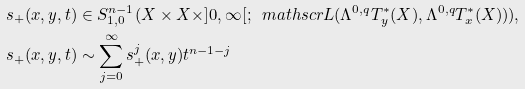<formula> <loc_0><loc_0><loc_500><loc_500>& s _ { + } ( x , y , t ) \in S ^ { n - 1 } _ { 1 , 0 } ( X \times X \times ] 0 , \infty [ ; \, \ m a t h s c r L ( \Lambda ^ { 0 , q } T ^ { * } _ { y } ( X ) , \Lambda ^ { 0 , q } T ^ { * } _ { x } ( X ) ) ) , \\ & s _ { + } ( x , y , t ) \sim \sum ^ { \infty } _ { j = 0 } s ^ { j } _ { + } ( x , y ) t ^ { n - 1 - j }</formula> 